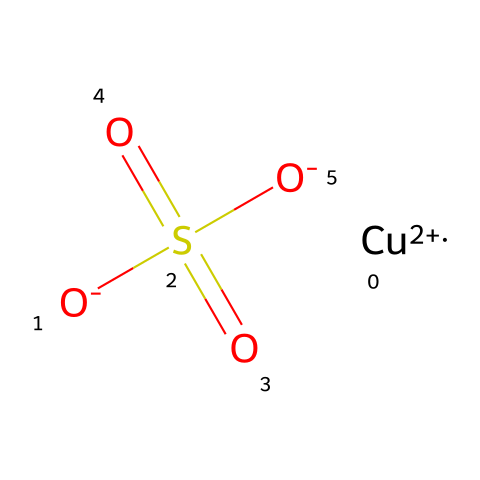What is the central metal atom in this structure? The chemical structure shows that there is a distinct copper ion denoted as [Cu+2], which is the central metal atom in the molecule.
Answer: copper How many oxygen atoms are present in this molecule? Analyzing the SMILES representation reveals there are three oxygen atoms bonded to the sulfur atom (O atoms are shown as [O-]), making it a total of three.
Answer: three What is the oxidation state of copper in this compound? The notation [Cu+2] indicates that copper has a +2 oxidation state, which is common for copper salts and fungicides.
Answer: +2 What type of functional group is present in this chemical? The structure contains a sulfonate group (S(=O)(=O)[O-]), as indicated by the sulfur atom bonded to three oxygen atoms, including two double-bonded ones.
Answer: sulfonate Is this chemical likely to be water-soluble? The presence of multiple ionic and polar functional groups including the sulfonate suggests that copper sulfate is highly soluble in water.
Answer: yes 